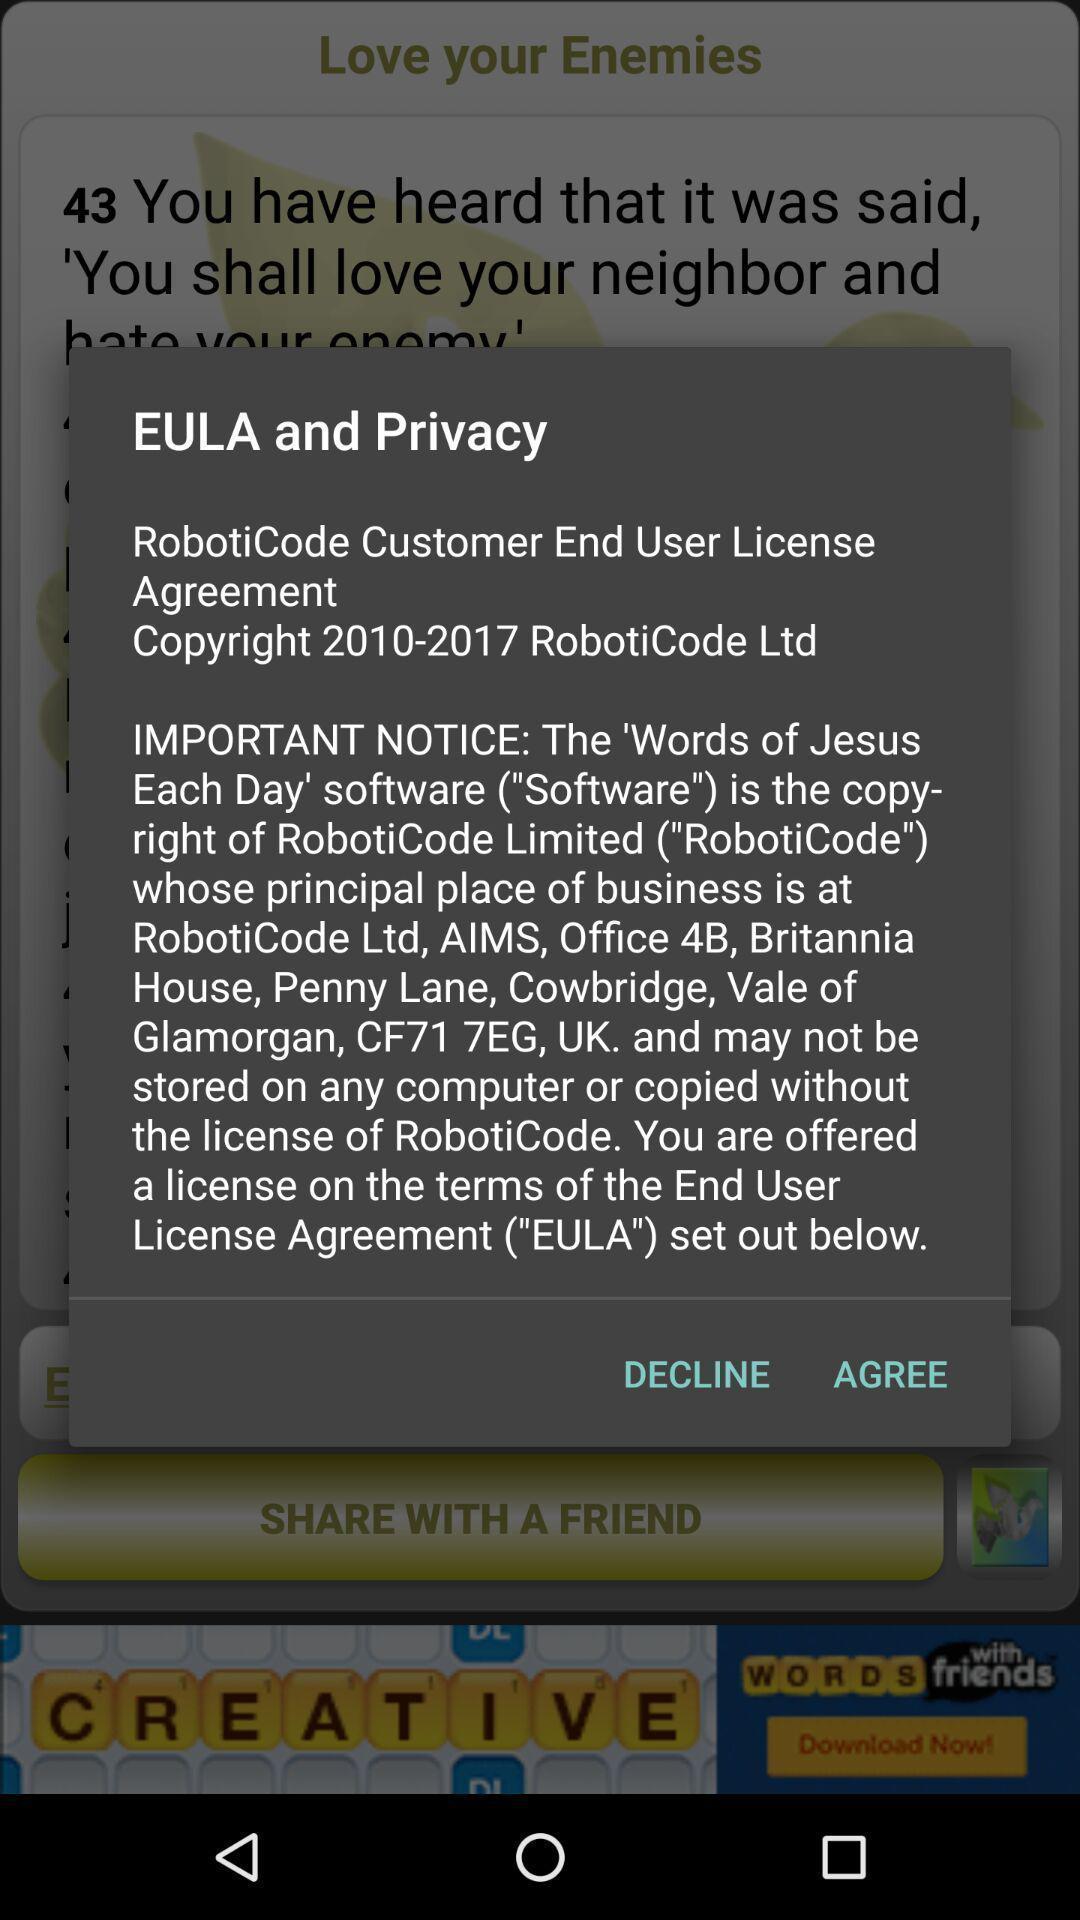Summarize the main components in this picture. Popup showing few instructions in holy-book app. 